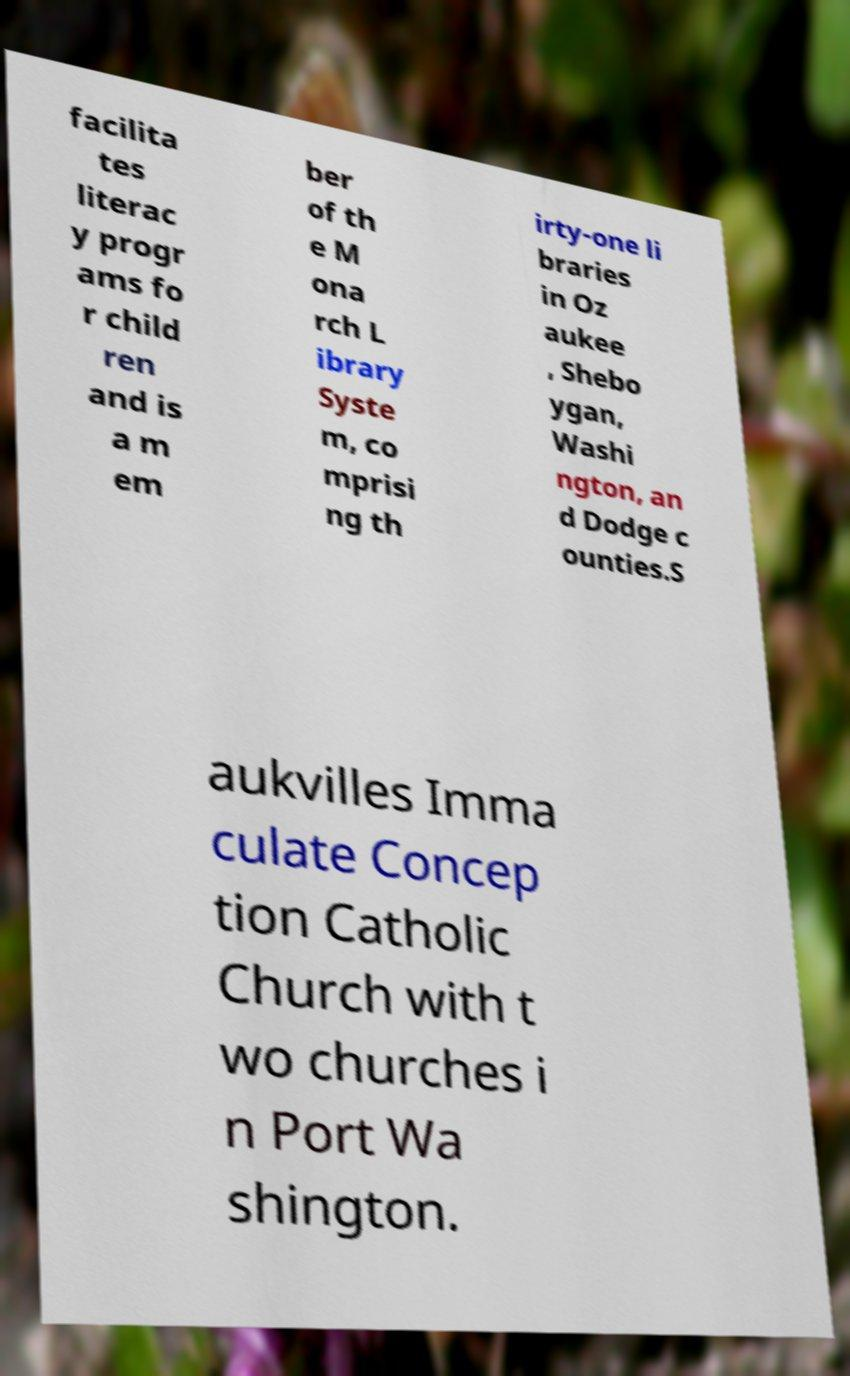Can you read and provide the text displayed in the image?This photo seems to have some interesting text. Can you extract and type it out for me? facilita tes literac y progr ams fo r child ren and is a m em ber of th e M ona rch L ibrary Syste m, co mprisi ng th irty-one li braries in Oz aukee , Shebo ygan, Washi ngton, an d Dodge c ounties.S aukvilles Imma culate Concep tion Catholic Church with t wo churches i n Port Wa shington. 